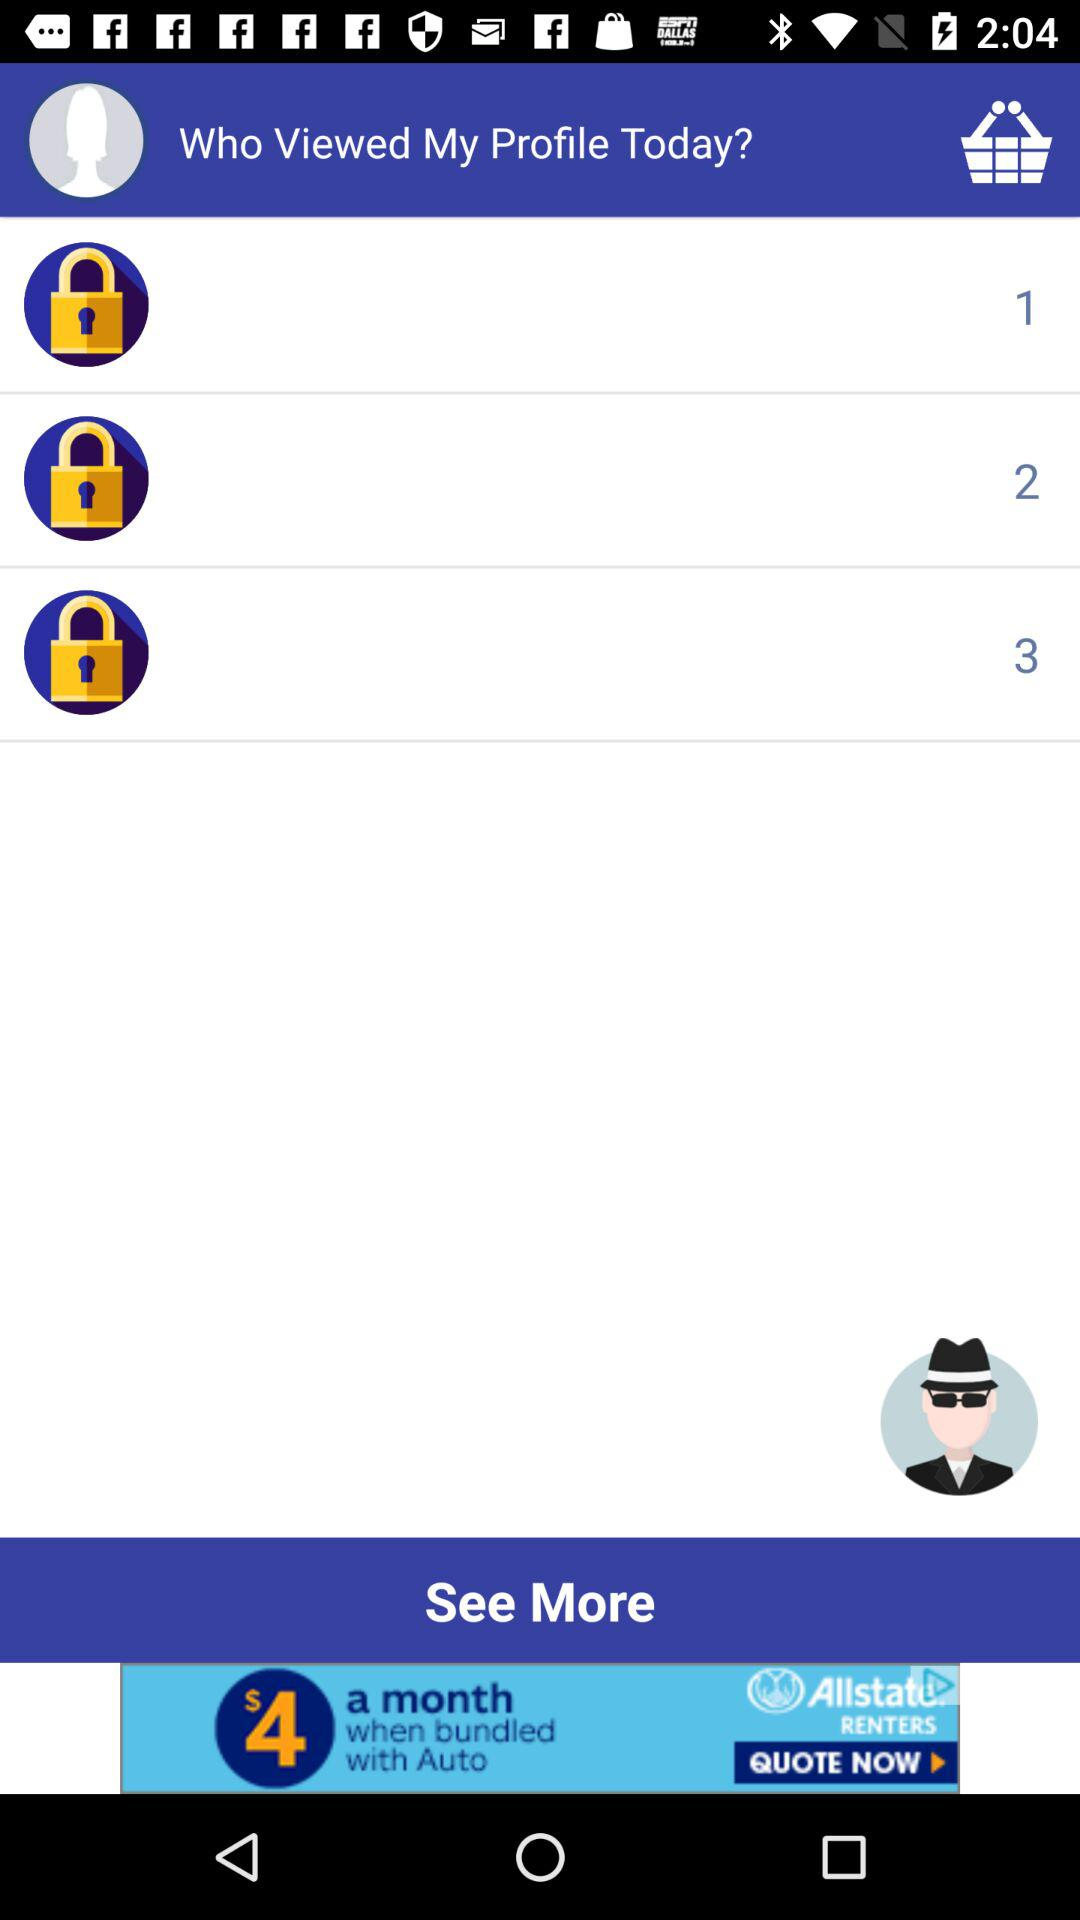How many people viewed my profile today?
Answer the question using a single word or phrase. 3 